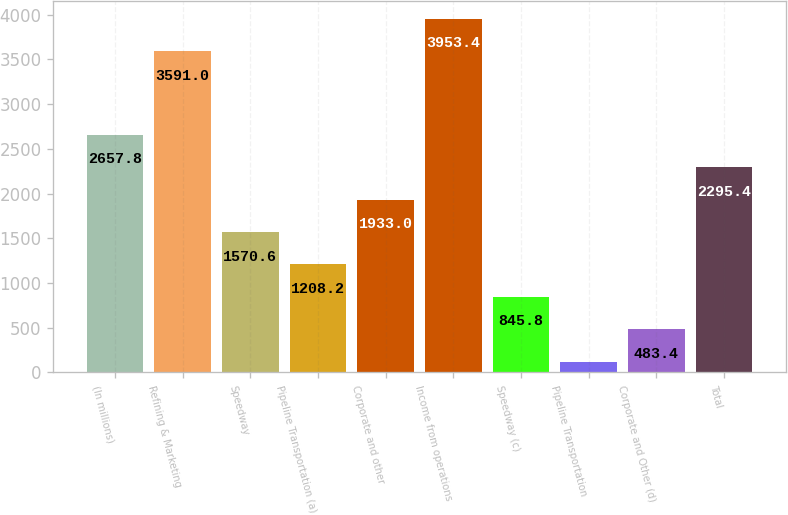Convert chart. <chart><loc_0><loc_0><loc_500><loc_500><bar_chart><fcel>(In millions)<fcel>Refining & Marketing<fcel>Speedway<fcel>Pipeline Transportation (a)<fcel>Corporate and other<fcel>Income from operations<fcel>Speedway (c)<fcel>Pipeline Transportation<fcel>Corporate and Other (d)<fcel>Total<nl><fcel>2657.8<fcel>3591<fcel>1570.6<fcel>1208.2<fcel>1933<fcel>3953.4<fcel>845.8<fcel>121<fcel>483.4<fcel>2295.4<nl></chart> 